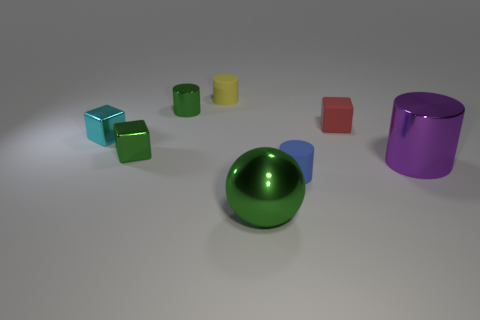Is the number of blocks that are to the right of the tiny metallic cylinder greater than the number of purple spheres?
Your answer should be compact. Yes. Is the shape of the blue thing the same as the tiny green metallic object behind the tiny green cube?
Provide a succinct answer. Yes. How many cylinders are the same size as the green sphere?
Offer a terse response. 1. There is a matte cylinder that is in front of the rubber cylinder behind the cyan metal cube; how many balls are in front of it?
Give a very brief answer. 1. Are there an equal number of large shiny spheres that are in front of the tiny blue rubber thing and large metal things to the left of the red block?
Your answer should be very brief. Yes. How many red matte things are the same shape as the big green metal thing?
Your answer should be compact. 0. Are there any large purple cylinders that have the same material as the large ball?
Provide a succinct answer. Yes. The small shiny thing that is the same color as the tiny metallic cylinder is what shape?
Keep it short and to the point. Cube. What number of big cyan cylinders are there?
Provide a short and direct response. 0. How many cylinders are brown rubber things or large purple metal objects?
Your answer should be very brief. 1. 